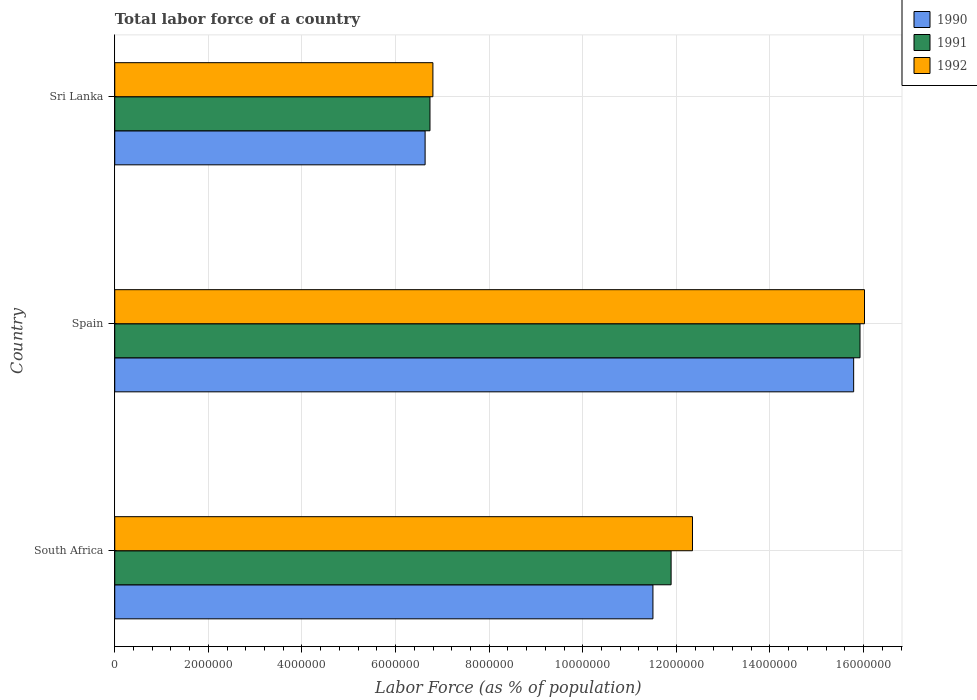How many groups of bars are there?
Provide a succinct answer. 3. Are the number of bars per tick equal to the number of legend labels?
Offer a terse response. Yes. Are the number of bars on each tick of the Y-axis equal?
Provide a short and direct response. Yes. How many bars are there on the 1st tick from the top?
Your answer should be very brief. 3. In how many cases, is the number of bars for a given country not equal to the number of legend labels?
Provide a succinct answer. 0. What is the percentage of labor force in 1991 in Sri Lanka?
Provide a succinct answer. 6.74e+06. Across all countries, what is the maximum percentage of labor force in 1991?
Provide a succinct answer. 1.59e+07. Across all countries, what is the minimum percentage of labor force in 1991?
Provide a succinct answer. 6.74e+06. In which country was the percentage of labor force in 1990 maximum?
Provide a succinct answer. Spain. In which country was the percentage of labor force in 1992 minimum?
Your answer should be compact. Sri Lanka. What is the total percentage of labor force in 1992 in the graph?
Offer a terse response. 3.52e+07. What is the difference between the percentage of labor force in 1991 in Spain and that in Sri Lanka?
Provide a short and direct response. 9.19e+06. What is the difference between the percentage of labor force in 1992 in Sri Lanka and the percentage of labor force in 1991 in South Africa?
Your response must be concise. -5.09e+06. What is the average percentage of labor force in 1992 per country?
Your answer should be very brief. 1.17e+07. What is the difference between the percentage of labor force in 1991 and percentage of labor force in 1992 in South Africa?
Provide a succinct answer. -4.57e+05. What is the ratio of the percentage of labor force in 1992 in South Africa to that in Spain?
Keep it short and to the point. 0.77. Is the difference between the percentage of labor force in 1991 in Spain and Sri Lanka greater than the difference between the percentage of labor force in 1992 in Spain and Sri Lanka?
Make the answer very short. No. What is the difference between the highest and the second highest percentage of labor force in 1990?
Your answer should be compact. 4.29e+06. What is the difference between the highest and the lowest percentage of labor force in 1991?
Make the answer very short. 9.19e+06. In how many countries, is the percentage of labor force in 1992 greater than the average percentage of labor force in 1992 taken over all countries?
Your answer should be very brief. 2. Is the sum of the percentage of labor force in 1990 in South Africa and Sri Lanka greater than the maximum percentage of labor force in 1991 across all countries?
Your response must be concise. Yes. What does the 1st bar from the bottom in South Africa represents?
Offer a very short reply. 1990. Are all the bars in the graph horizontal?
Your answer should be very brief. Yes. Are the values on the major ticks of X-axis written in scientific E-notation?
Offer a terse response. No. What is the title of the graph?
Provide a short and direct response. Total labor force of a country. What is the label or title of the X-axis?
Your answer should be very brief. Labor Force (as % of population). What is the label or title of the Y-axis?
Keep it short and to the point. Country. What is the Labor Force (as % of population) in 1990 in South Africa?
Keep it short and to the point. 1.15e+07. What is the Labor Force (as % of population) of 1991 in South Africa?
Give a very brief answer. 1.19e+07. What is the Labor Force (as % of population) of 1992 in South Africa?
Offer a terse response. 1.23e+07. What is the Labor Force (as % of population) of 1990 in Spain?
Your response must be concise. 1.58e+07. What is the Labor Force (as % of population) in 1991 in Spain?
Provide a succinct answer. 1.59e+07. What is the Labor Force (as % of population) in 1992 in Spain?
Your answer should be very brief. 1.60e+07. What is the Labor Force (as % of population) in 1990 in Sri Lanka?
Your answer should be compact. 6.63e+06. What is the Labor Force (as % of population) in 1991 in Sri Lanka?
Offer a terse response. 6.74e+06. What is the Labor Force (as % of population) of 1992 in Sri Lanka?
Offer a very short reply. 6.80e+06. Across all countries, what is the maximum Labor Force (as % of population) of 1990?
Offer a very short reply. 1.58e+07. Across all countries, what is the maximum Labor Force (as % of population) of 1991?
Provide a short and direct response. 1.59e+07. Across all countries, what is the maximum Labor Force (as % of population) in 1992?
Ensure brevity in your answer.  1.60e+07. Across all countries, what is the minimum Labor Force (as % of population) in 1990?
Offer a terse response. 6.63e+06. Across all countries, what is the minimum Labor Force (as % of population) in 1991?
Ensure brevity in your answer.  6.74e+06. Across all countries, what is the minimum Labor Force (as % of population) in 1992?
Give a very brief answer. 6.80e+06. What is the total Labor Force (as % of population) of 1990 in the graph?
Make the answer very short. 3.39e+07. What is the total Labor Force (as % of population) in 1991 in the graph?
Provide a short and direct response. 3.45e+07. What is the total Labor Force (as % of population) of 1992 in the graph?
Give a very brief answer. 3.52e+07. What is the difference between the Labor Force (as % of population) in 1990 in South Africa and that in Spain?
Provide a short and direct response. -4.29e+06. What is the difference between the Labor Force (as % of population) of 1991 in South Africa and that in Spain?
Offer a very short reply. -4.04e+06. What is the difference between the Labor Force (as % of population) of 1992 in South Africa and that in Spain?
Make the answer very short. -3.68e+06. What is the difference between the Labor Force (as % of population) in 1990 in South Africa and that in Sri Lanka?
Ensure brevity in your answer.  4.87e+06. What is the difference between the Labor Force (as % of population) of 1991 in South Africa and that in Sri Lanka?
Offer a terse response. 5.15e+06. What is the difference between the Labor Force (as % of population) in 1992 in South Africa and that in Sri Lanka?
Provide a short and direct response. 5.55e+06. What is the difference between the Labor Force (as % of population) of 1990 in Spain and that in Sri Lanka?
Keep it short and to the point. 9.16e+06. What is the difference between the Labor Force (as % of population) of 1991 in Spain and that in Sri Lanka?
Provide a short and direct response. 9.19e+06. What is the difference between the Labor Force (as % of population) in 1992 in Spain and that in Sri Lanka?
Offer a terse response. 9.22e+06. What is the difference between the Labor Force (as % of population) of 1990 in South Africa and the Labor Force (as % of population) of 1991 in Spain?
Provide a short and direct response. -4.42e+06. What is the difference between the Labor Force (as % of population) of 1990 in South Africa and the Labor Force (as % of population) of 1992 in Spain?
Give a very brief answer. -4.52e+06. What is the difference between the Labor Force (as % of population) in 1991 in South Africa and the Labor Force (as % of population) in 1992 in Spain?
Your response must be concise. -4.13e+06. What is the difference between the Labor Force (as % of population) of 1990 in South Africa and the Labor Force (as % of population) of 1991 in Sri Lanka?
Offer a terse response. 4.76e+06. What is the difference between the Labor Force (as % of population) in 1990 in South Africa and the Labor Force (as % of population) in 1992 in Sri Lanka?
Give a very brief answer. 4.70e+06. What is the difference between the Labor Force (as % of population) in 1991 in South Africa and the Labor Force (as % of population) in 1992 in Sri Lanka?
Your answer should be compact. 5.09e+06. What is the difference between the Labor Force (as % of population) in 1990 in Spain and the Labor Force (as % of population) in 1991 in Sri Lanka?
Keep it short and to the point. 9.05e+06. What is the difference between the Labor Force (as % of population) of 1990 in Spain and the Labor Force (as % of population) of 1992 in Sri Lanka?
Provide a short and direct response. 8.99e+06. What is the difference between the Labor Force (as % of population) of 1991 in Spain and the Labor Force (as % of population) of 1992 in Sri Lanka?
Your answer should be very brief. 9.13e+06. What is the average Labor Force (as % of population) of 1990 per country?
Your response must be concise. 1.13e+07. What is the average Labor Force (as % of population) in 1991 per country?
Your response must be concise. 1.15e+07. What is the average Labor Force (as % of population) of 1992 per country?
Your answer should be very brief. 1.17e+07. What is the difference between the Labor Force (as % of population) in 1990 and Labor Force (as % of population) in 1991 in South Africa?
Offer a terse response. -3.88e+05. What is the difference between the Labor Force (as % of population) in 1990 and Labor Force (as % of population) in 1992 in South Africa?
Offer a very short reply. -8.45e+05. What is the difference between the Labor Force (as % of population) in 1991 and Labor Force (as % of population) in 1992 in South Africa?
Offer a very short reply. -4.57e+05. What is the difference between the Labor Force (as % of population) in 1990 and Labor Force (as % of population) in 1991 in Spain?
Keep it short and to the point. -1.36e+05. What is the difference between the Labor Force (as % of population) of 1990 and Labor Force (as % of population) of 1992 in Spain?
Your answer should be compact. -2.32e+05. What is the difference between the Labor Force (as % of population) of 1991 and Labor Force (as % of population) of 1992 in Spain?
Keep it short and to the point. -9.58e+04. What is the difference between the Labor Force (as % of population) of 1990 and Labor Force (as % of population) of 1991 in Sri Lanka?
Your answer should be very brief. -1.04e+05. What is the difference between the Labor Force (as % of population) in 1990 and Labor Force (as % of population) in 1992 in Sri Lanka?
Your answer should be compact. -1.67e+05. What is the difference between the Labor Force (as % of population) of 1991 and Labor Force (as % of population) of 1992 in Sri Lanka?
Ensure brevity in your answer.  -6.25e+04. What is the ratio of the Labor Force (as % of population) in 1990 in South Africa to that in Spain?
Ensure brevity in your answer.  0.73. What is the ratio of the Labor Force (as % of population) in 1991 in South Africa to that in Spain?
Offer a very short reply. 0.75. What is the ratio of the Labor Force (as % of population) of 1992 in South Africa to that in Spain?
Provide a short and direct response. 0.77. What is the ratio of the Labor Force (as % of population) in 1990 in South Africa to that in Sri Lanka?
Your response must be concise. 1.73. What is the ratio of the Labor Force (as % of population) in 1991 in South Africa to that in Sri Lanka?
Keep it short and to the point. 1.76. What is the ratio of the Labor Force (as % of population) in 1992 in South Africa to that in Sri Lanka?
Your response must be concise. 1.82. What is the ratio of the Labor Force (as % of population) in 1990 in Spain to that in Sri Lanka?
Your answer should be very brief. 2.38. What is the ratio of the Labor Force (as % of population) of 1991 in Spain to that in Sri Lanka?
Make the answer very short. 2.36. What is the ratio of the Labor Force (as % of population) in 1992 in Spain to that in Sri Lanka?
Ensure brevity in your answer.  2.36. What is the difference between the highest and the second highest Labor Force (as % of population) in 1990?
Your response must be concise. 4.29e+06. What is the difference between the highest and the second highest Labor Force (as % of population) of 1991?
Keep it short and to the point. 4.04e+06. What is the difference between the highest and the second highest Labor Force (as % of population) in 1992?
Your response must be concise. 3.68e+06. What is the difference between the highest and the lowest Labor Force (as % of population) in 1990?
Your answer should be compact. 9.16e+06. What is the difference between the highest and the lowest Labor Force (as % of population) of 1991?
Make the answer very short. 9.19e+06. What is the difference between the highest and the lowest Labor Force (as % of population) of 1992?
Your answer should be very brief. 9.22e+06. 